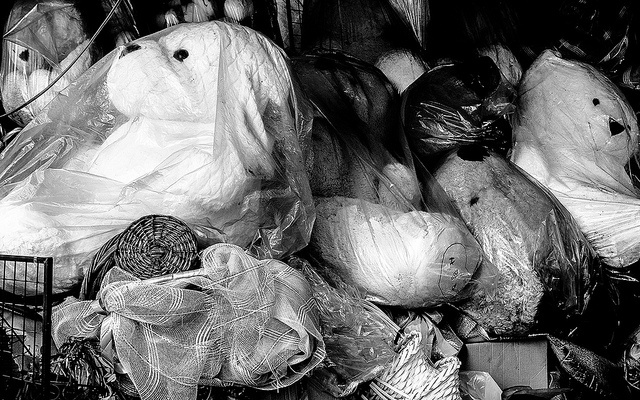Describe the objects in this image and their specific colors. I can see teddy bear in black, lightgray, darkgray, and gray tones, teddy bear in black, gray, darkgray, and lightgray tones, teddy bear in black, lightgray, gray, and darkgray tones, teddy bear in black, darkgray, lightgray, and gray tones, and teddy bear in black, darkgray, lightgray, and gray tones in this image. 